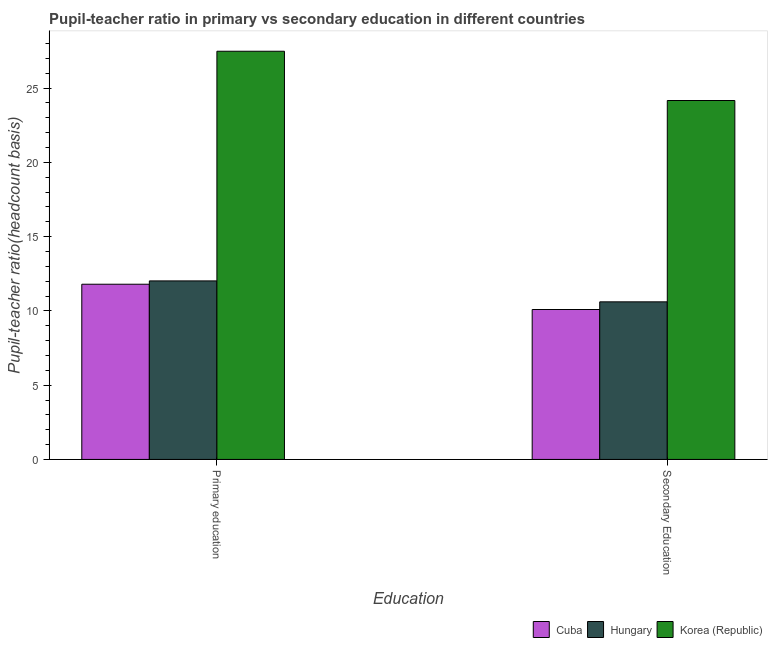Are the number of bars per tick equal to the number of legend labels?
Your response must be concise. Yes. How many bars are there on the 1st tick from the right?
Make the answer very short. 3. What is the label of the 2nd group of bars from the left?
Keep it short and to the point. Secondary Education. What is the pupil teacher ratio on secondary education in Cuba?
Offer a terse response. 10.09. Across all countries, what is the maximum pupil-teacher ratio in primary education?
Your answer should be compact. 27.48. Across all countries, what is the minimum pupil-teacher ratio in primary education?
Offer a very short reply. 11.8. In which country was the pupil-teacher ratio in primary education minimum?
Your answer should be compact. Cuba. What is the total pupil-teacher ratio in primary education in the graph?
Offer a very short reply. 51.3. What is the difference between the pupil teacher ratio on secondary education in Hungary and that in Korea (Republic)?
Keep it short and to the point. -13.55. What is the difference between the pupil teacher ratio on secondary education in Hungary and the pupil-teacher ratio in primary education in Korea (Republic)?
Keep it short and to the point. -16.87. What is the average pupil teacher ratio on secondary education per country?
Ensure brevity in your answer.  14.96. What is the difference between the pupil-teacher ratio in primary education and pupil teacher ratio on secondary education in Korea (Republic)?
Provide a succinct answer. 3.32. What is the ratio of the pupil teacher ratio on secondary education in Korea (Republic) to that in Cuba?
Offer a terse response. 2.39. Is the pupil teacher ratio on secondary education in Hungary less than that in Korea (Republic)?
Offer a very short reply. Yes. What does the 2nd bar from the left in Primary education represents?
Offer a very short reply. Hungary. What does the 2nd bar from the right in Primary education represents?
Your answer should be very brief. Hungary. Are the values on the major ticks of Y-axis written in scientific E-notation?
Your response must be concise. No. How many legend labels are there?
Offer a very short reply. 3. What is the title of the graph?
Offer a very short reply. Pupil-teacher ratio in primary vs secondary education in different countries. Does "Trinidad and Tobago" appear as one of the legend labels in the graph?
Provide a succinct answer. No. What is the label or title of the X-axis?
Keep it short and to the point. Education. What is the label or title of the Y-axis?
Offer a terse response. Pupil-teacher ratio(headcount basis). What is the Pupil-teacher ratio(headcount basis) of Cuba in Primary education?
Ensure brevity in your answer.  11.8. What is the Pupil-teacher ratio(headcount basis) of Hungary in Primary education?
Your answer should be very brief. 12.02. What is the Pupil-teacher ratio(headcount basis) in Korea (Republic) in Primary education?
Ensure brevity in your answer.  27.48. What is the Pupil-teacher ratio(headcount basis) in Cuba in Secondary Education?
Ensure brevity in your answer.  10.09. What is the Pupil-teacher ratio(headcount basis) of Hungary in Secondary Education?
Make the answer very short. 10.61. What is the Pupil-teacher ratio(headcount basis) in Korea (Republic) in Secondary Education?
Ensure brevity in your answer.  24.16. Across all Education, what is the maximum Pupil-teacher ratio(headcount basis) of Cuba?
Keep it short and to the point. 11.8. Across all Education, what is the maximum Pupil-teacher ratio(headcount basis) in Hungary?
Offer a terse response. 12.02. Across all Education, what is the maximum Pupil-teacher ratio(headcount basis) of Korea (Republic)?
Provide a succinct answer. 27.48. Across all Education, what is the minimum Pupil-teacher ratio(headcount basis) in Cuba?
Keep it short and to the point. 10.09. Across all Education, what is the minimum Pupil-teacher ratio(headcount basis) in Hungary?
Give a very brief answer. 10.61. Across all Education, what is the minimum Pupil-teacher ratio(headcount basis) of Korea (Republic)?
Your answer should be compact. 24.16. What is the total Pupil-teacher ratio(headcount basis) of Cuba in the graph?
Offer a very short reply. 21.89. What is the total Pupil-teacher ratio(headcount basis) in Hungary in the graph?
Your response must be concise. 22.63. What is the total Pupil-teacher ratio(headcount basis) in Korea (Republic) in the graph?
Provide a short and direct response. 51.65. What is the difference between the Pupil-teacher ratio(headcount basis) in Cuba in Primary education and that in Secondary Education?
Offer a very short reply. 1.7. What is the difference between the Pupil-teacher ratio(headcount basis) of Hungary in Primary education and that in Secondary Education?
Your response must be concise. 1.41. What is the difference between the Pupil-teacher ratio(headcount basis) of Korea (Republic) in Primary education and that in Secondary Education?
Give a very brief answer. 3.32. What is the difference between the Pupil-teacher ratio(headcount basis) in Cuba in Primary education and the Pupil-teacher ratio(headcount basis) in Hungary in Secondary Education?
Your response must be concise. 1.19. What is the difference between the Pupil-teacher ratio(headcount basis) in Cuba in Primary education and the Pupil-teacher ratio(headcount basis) in Korea (Republic) in Secondary Education?
Ensure brevity in your answer.  -12.37. What is the difference between the Pupil-teacher ratio(headcount basis) in Hungary in Primary education and the Pupil-teacher ratio(headcount basis) in Korea (Republic) in Secondary Education?
Keep it short and to the point. -12.15. What is the average Pupil-teacher ratio(headcount basis) of Cuba per Education?
Offer a very short reply. 10.94. What is the average Pupil-teacher ratio(headcount basis) in Hungary per Education?
Offer a very short reply. 11.31. What is the average Pupil-teacher ratio(headcount basis) in Korea (Republic) per Education?
Your answer should be compact. 25.82. What is the difference between the Pupil-teacher ratio(headcount basis) in Cuba and Pupil-teacher ratio(headcount basis) in Hungary in Primary education?
Your answer should be very brief. -0.22. What is the difference between the Pupil-teacher ratio(headcount basis) of Cuba and Pupil-teacher ratio(headcount basis) of Korea (Republic) in Primary education?
Make the answer very short. -15.69. What is the difference between the Pupil-teacher ratio(headcount basis) of Hungary and Pupil-teacher ratio(headcount basis) of Korea (Republic) in Primary education?
Ensure brevity in your answer.  -15.46. What is the difference between the Pupil-teacher ratio(headcount basis) in Cuba and Pupil-teacher ratio(headcount basis) in Hungary in Secondary Education?
Provide a succinct answer. -0.52. What is the difference between the Pupil-teacher ratio(headcount basis) in Cuba and Pupil-teacher ratio(headcount basis) in Korea (Republic) in Secondary Education?
Give a very brief answer. -14.07. What is the difference between the Pupil-teacher ratio(headcount basis) of Hungary and Pupil-teacher ratio(headcount basis) of Korea (Republic) in Secondary Education?
Your answer should be compact. -13.55. What is the ratio of the Pupil-teacher ratio(headcount basis) of Cuba in Primary education to that in Secondary Education?
Offer a very short reply. 1.17. What is the ratio of the Pupil-teacher ratio(headcount basis) of Hungary in Primary education to that in Secondary Education?
Offer a very short reply. 1.13. What is the ratio of the Pupil-teacher ratio(headcount basis) in Korea (Republic) in Primary education to that in Secondary Education?
Offer a very short reply. 1.14. What is the difference between the highest and the second highest Pupil-teacher ratio(headcount basis) in Cuba?
Make the answer very short. 1.7. What is the difference between the highest and the second highest Pupil-teacher ratio(headcount basis) in Hungary?
Make the answer very short. 1.41. What is the difference between the highest and the second highest Pupil-teacher ratio(headcount basis) in Korea (Republic)?
Offer a terse response. 3.32. What is the difference between the highest and the lowest Pupil-teacher ratio(headcount basis) in Cuba?
Keep it short and to the point. 1.7. What is the difference between the highest and the lowest Pupil-teacher ratio(headcount basis) in Hungary?
Your answer should be compact. 1.41. What is the difference between the highest and the lowest Pupil-teacher ratio(headcount basis) in Korea (Republic)?
Your answer should be compact. 3.32. 